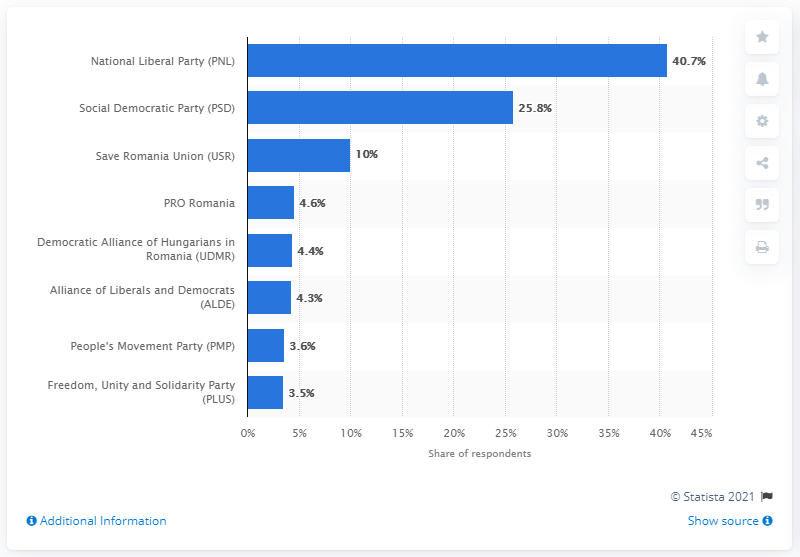Highlight a few significant elements in this photo. The value for PRO Romania is 4.6. Out of the categories, how many have a percentage of less than 9%? 